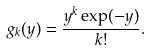<formula> <loc_0><loc_0><loc_500><loc_500>g _ { k } ( y ) = \frac { y ^ { k } \exp ( - y ) } { k ! } .</formula> 